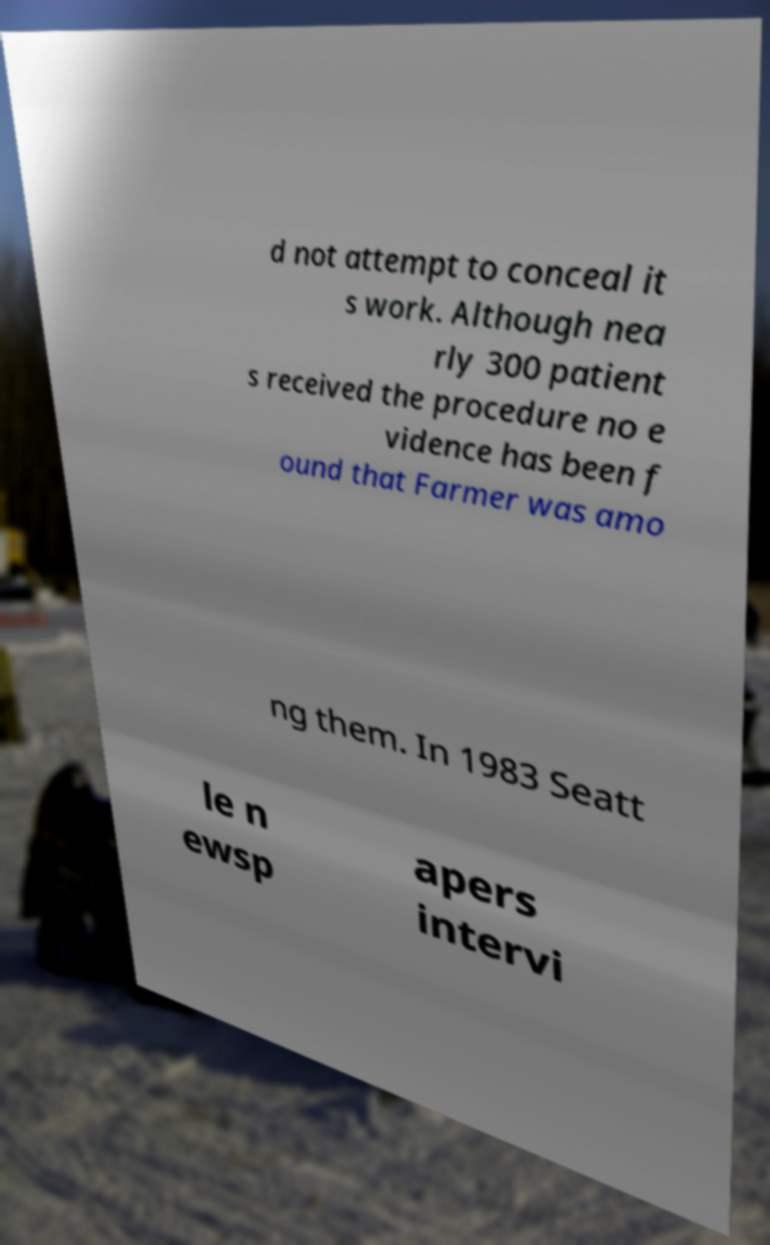Could you assist in decoding the text presented in this image and type it out clearly? d not attempt to conceal it s work. Although nea rly 300 patient s received the procedure no e vidence has been f ound that Farmer was amo ng them. In 1983 Seatt le n ewsp apers intervi 